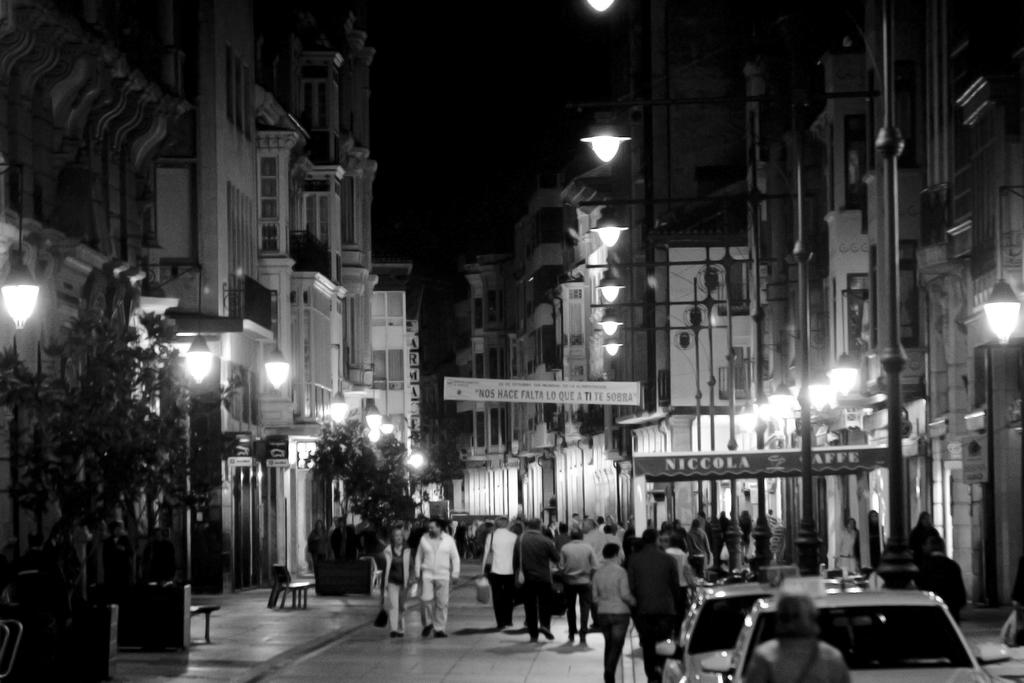What is the color scheme of the image? The image is black and white. What are the people in the image doing? There are many people walking in the image. What is the main feature of the image? There is a path in the image, with buildings on either side. What type of vegetation can be seen in the image? Trees are visible in the image. What structures are present to provide light in the image? Street lights are present in the image. How many frogs are hopping on the path in the image? There are no frogs present in the image; it features people walking on a path with buildings and trees. What type of club can be seen in the image? There is no club present in the image; it is a black and white scene with people walking on a path. 